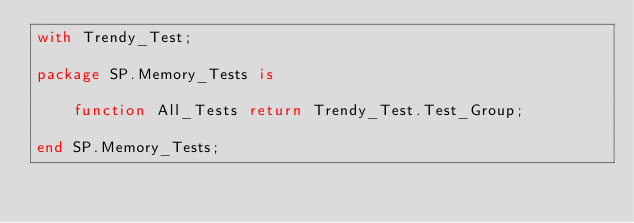<code> <loc_0><loc_0><loc_500><loc_500><_Ada_>with Trendy_Test;

package SP.Memory_Tests is

    function All_Tests return Trendy_Test.Test_Group;

end SP.Memory_Tests;
</code> 